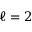Convert formula to latex. <formula><loc_0><loc_0><loc_500><loc_500>\ell = 2</formula> 